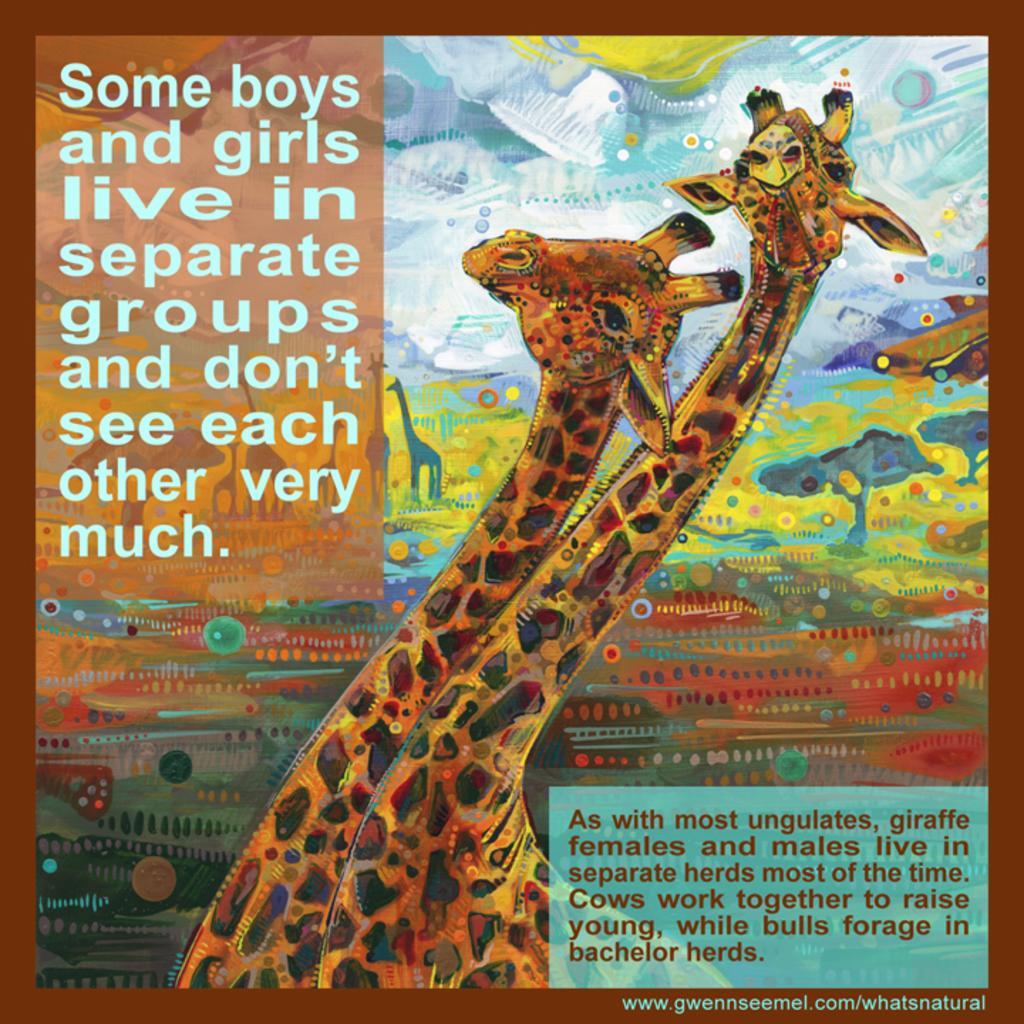Could you give a brief overview of what you see in this image? In this picture there is a poster, in the center there are sketches of giraffes and trees. At the top left and at the bottom right there is some text. 